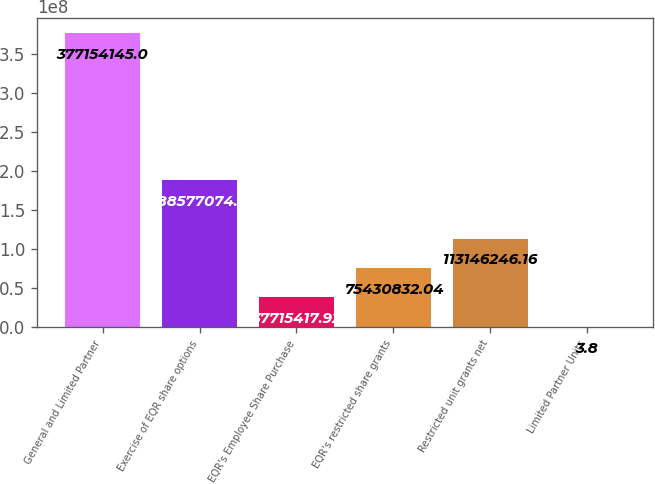Convert chart. <chart><loc_0><loc_0><loc_500><loc_500><bar_chart><fcel>General and Limited Partner<fcel>Exercise of EQR share options<fcel>EQR's Employee Share Purchase<fcel>EQR's restricted share grants<fcel>Restricted unit grants net<fcel>Limited Partner Units<nl><fcel>3.77154e+08<fcel>1.88577e+08<fcel>3.77154e+07<fcel>7.54308e+07<fcel>1.13146e+08<fcel>3.8<nl></chart> 